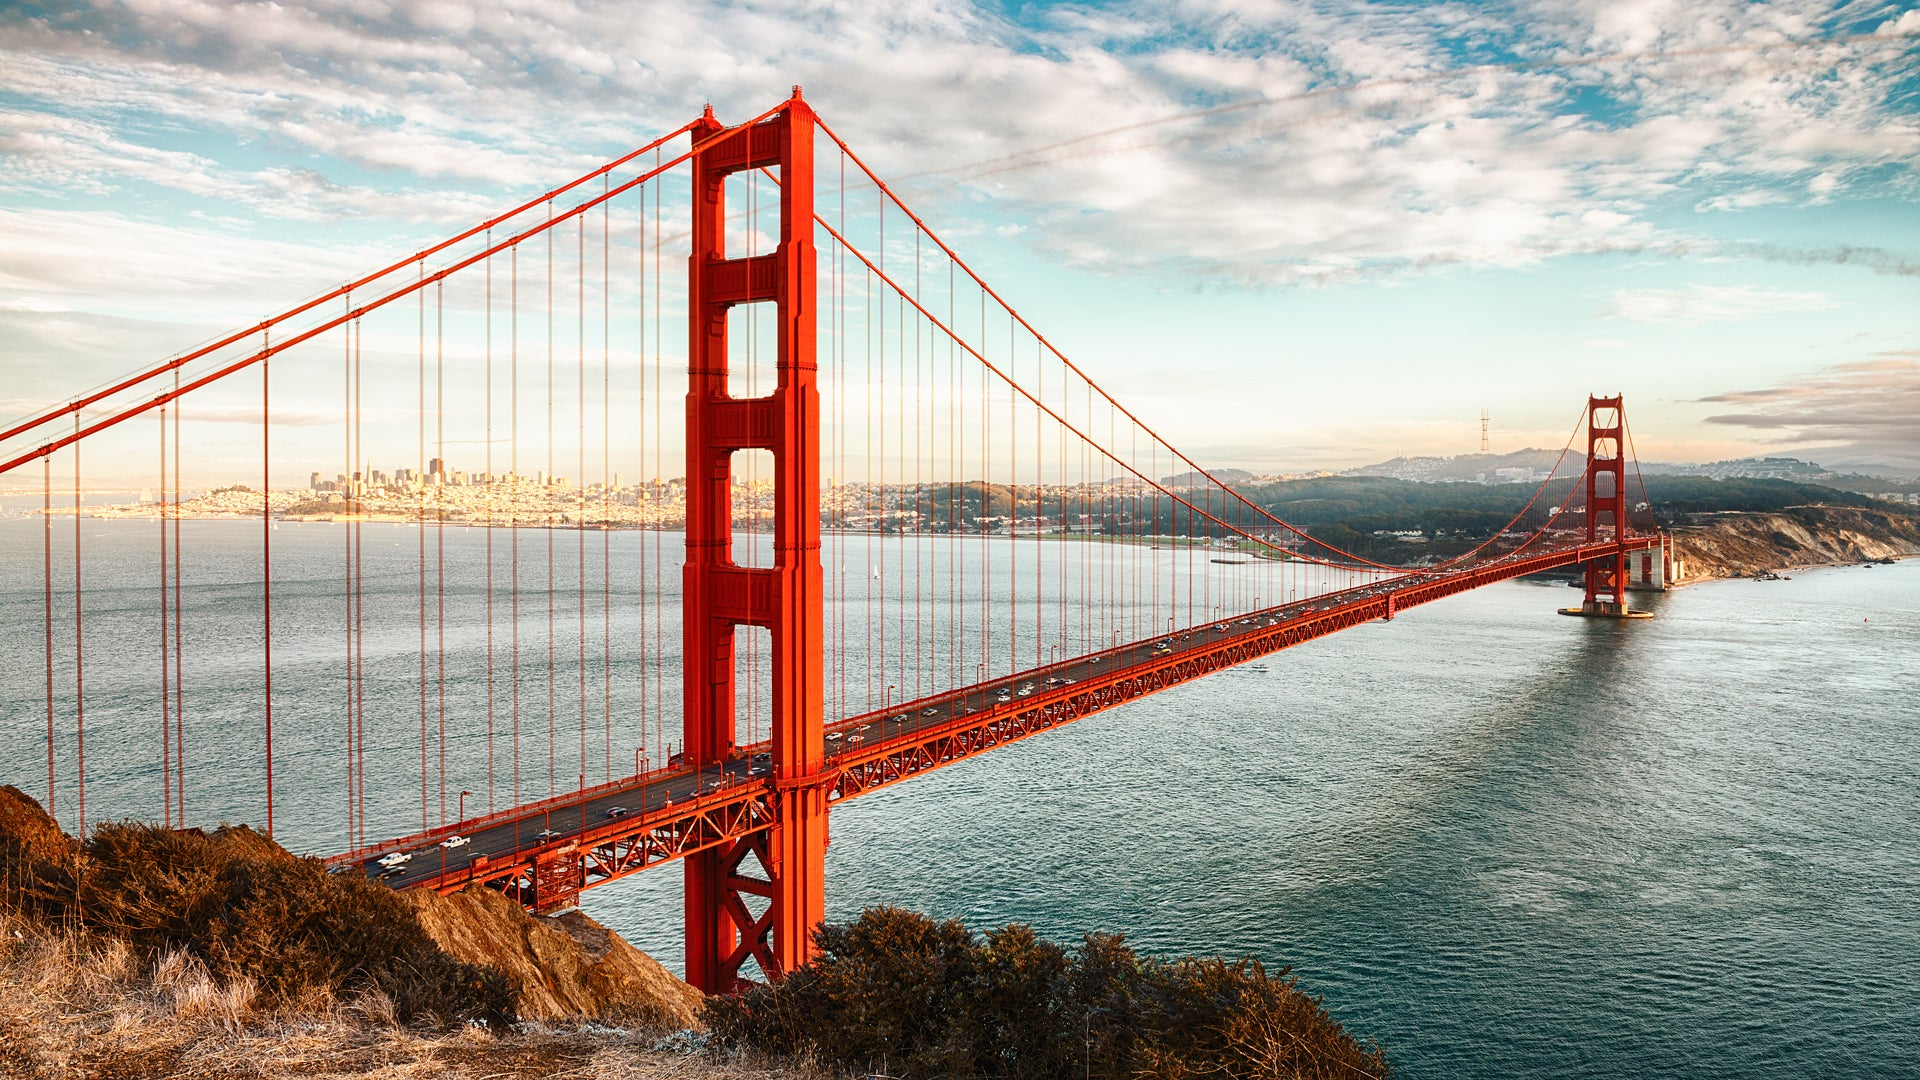How might the scene change if it were nighttime? At nighttime, the Golden Gate Bridge transforms into a luminous beacon against the darkened sky. The bridge's magnificent towers are adorned with gleaming lights, casting a warm golden glow that reflects on the water below. The city skyline in the distance twinkles with countless lights, adding to the enchanting atmosphere. The red cables and structure of the bridge are illuminated, creating a striking silhouette against the starlit backdrop. The serene water mirrors the glittering lights, creating a mesmerizing and almost magical scene that invites contemplation and wonder. 